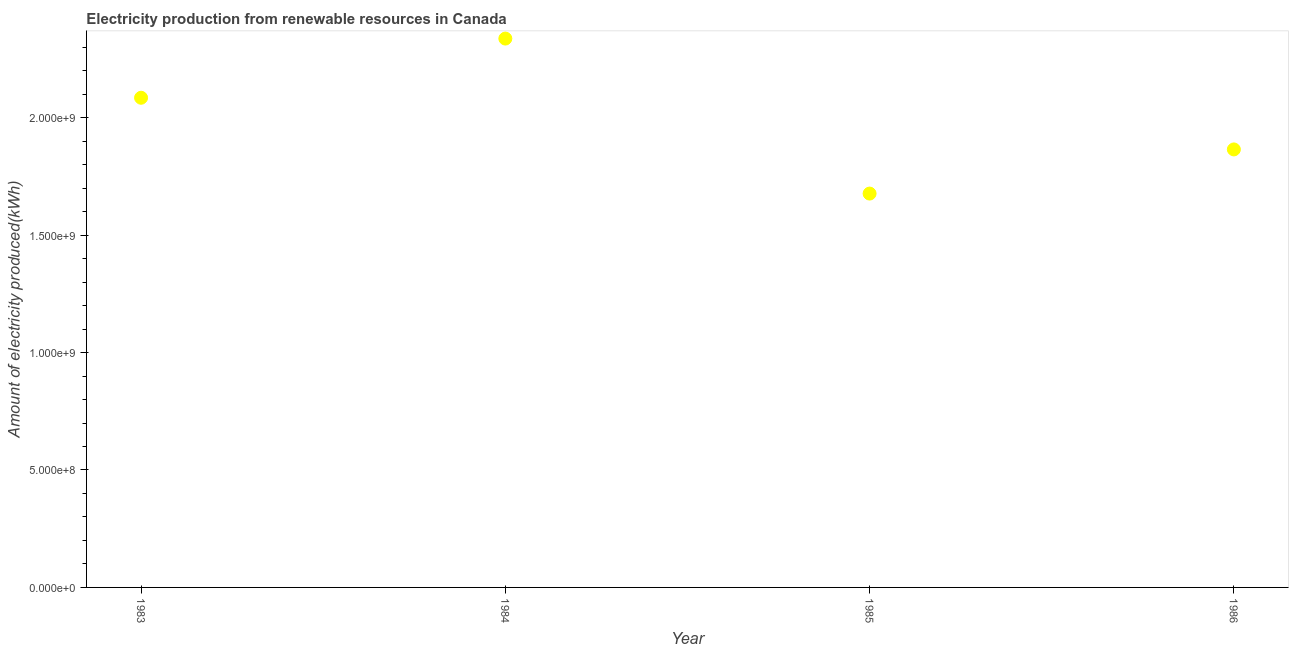What is the amount of electricity produced in 1983?
Ensure brevity in your answer.  2.08e+09. Across all years, what is the maximum amount of electricity produced?
Make the answer very short. 2.34e+09. Across all years, what is the minimum amount of electricity produced?
Your answer should be compact. 1.68e+09. In which year was the amount of electricity produced minimum?
Provide a short and direct response. 1985. What is the sum of the amount of electricity produced?
Give a very brief answer. 7.96e+09. What is the difference between the amount of electricity produced in 1985 and 1986?
Your answer should be very brief. -1.88e+08. What is the average amount of electricity produced per year?
Offer a very short reply. 1.99e+09. What is the median amount of electricity produced?
Make the answer very short. 1.98e+09. In how many years, is the amount of electricity produced greater than 1100000000 kWh?
Give a very brief answer. 4. Do a majority of the years between 1984 and 1983 (inclusive) have amount of electricity produced greater than 400000000 kWh?
Ensure brevity in your answer.  No. What is the ratio of the amount of electricity produced in 1985 to that in 1986?
Your response must be concise. 0.9. Is the difference between the amount of electricity produced in 1983 and 1985 greater than the difference between any two years?
Give a very brief answer. No. What is the difference between the highest and the second highest amount of electricity produced?
Ensure brevity in your answer.  2.52e+08. Is the sum of the amount of electricity produced in 1983 and 1984 greater than the maximum amount of electricity produced across all years?
Make the answer very short. Yes. What is the difference between the highest and the lowest amount of electricity produced?
Provide a short and direct response. 6.60e+08. How many years are there in the graph?
Provide a short and direct response. 4. What is the difference between two consecutive major ticks on the Y-axis?
Offer a very short reply. 5.00e+08. Does the graph contain any zero values?
Your response must be concise. No. What is the title of the graph?
Your answer should be compact. Electricity production from renewable resources in Canada. What is the label or title of the X-axis?
Your answer should be very brief. Year. What is the label or title of the Y-axis?
Your answer should be very brief. Amount of electricity produced(kWh). What is the Amount of electricity produced(kWh) in 1983?
Your response must be concise. 2.08e+09. What is the Amount of electricity produced(kWh) in 1984?
Provide a short and direct response. 2.34e+09. What is the Amount of electricity produced(kWh) in 1985?
Make the answer very short. 1.68e+09. What is the Amount of electricity produced(kWh) in 1986?
Offer a terse response. 1.86e+09. What is the difference between the Amount of electricity produced(kWh) in 1983 and 1984?
Offer a very short reply. -2.52e+08. What is the difference between the Amount of electricity produced(kWh) in 1983 and 1985?
Provide a short and direct response. 4.08e+08. What is the difference between the Amount of electricity produced(kWh) in 1983 and 1986?
Provide a succinct answer. 2.20e+08. What is the difference between the Amount of electricity produced(kWh) in 1984 and 1985?
Provide a short and direct response. 6.60e+08. What is the difference between the Amount of electricity produced(kWh) in 1984 and 1986?
Offer a terse response. 4.72e+08. What is the difference between the Amount of electricity produced(kWh) in 1985 and 1986?
Provide a succinct answer. -1.88e+08. What is the ratio of the Amount of electricity produced(kWh) in 1983 to that in 1984?
Provide a succinct answer. 0.89. What is the ratio of the Amount of electricity produced(kWh) in 1983 to that in 1985?
Offer a very short reply. 1.24. What is the ratio of the Amount of electricity produced(kWh) in 1983 to that in 1986?
Your answer should be very brief. 1.12. What is the ratio of the Amount of electricity produced(kWh) in 1984 to that in 1985?
Ensure brevity in your answer.  1.39. What is the ratio of the Amount of electricity produced(kWh) in 1984 to that in 1986?
Make the answer very short. 1.25. What is the ratio of the Amount of electricity produced(kWh) in 1985 to that in 1986?
Your response must be concise. 0.9. 